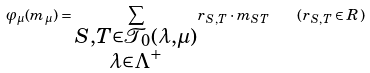Convert formula to latex. <formula><loc_0><loc_0><loc_500><loc_500>\varphi _ { \mu } ( m _ { \mu } ) = \underset { \substack { S , T \in \mathcal { T } _ { 0 } ( \lambda , \mu ) \\ \lambda \in \Lambda ^ { + } } } { \sum } r _ { S , T } \cdot m _ { S T } \quad ( r _ { S , T } \in R )</formula> 